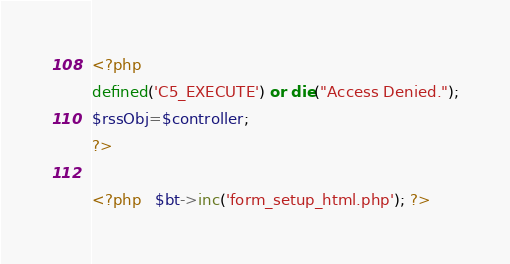Convert code to text. <code><loc_0><loc_0><loc_500><loc_500><_PHP_><?php 
defined('C5_EXECUTE') or die("Access Denied.");
$rssObj=$controller;
?>

<?php   $bt->inc('form_setup_html.php'); ?> </code> 